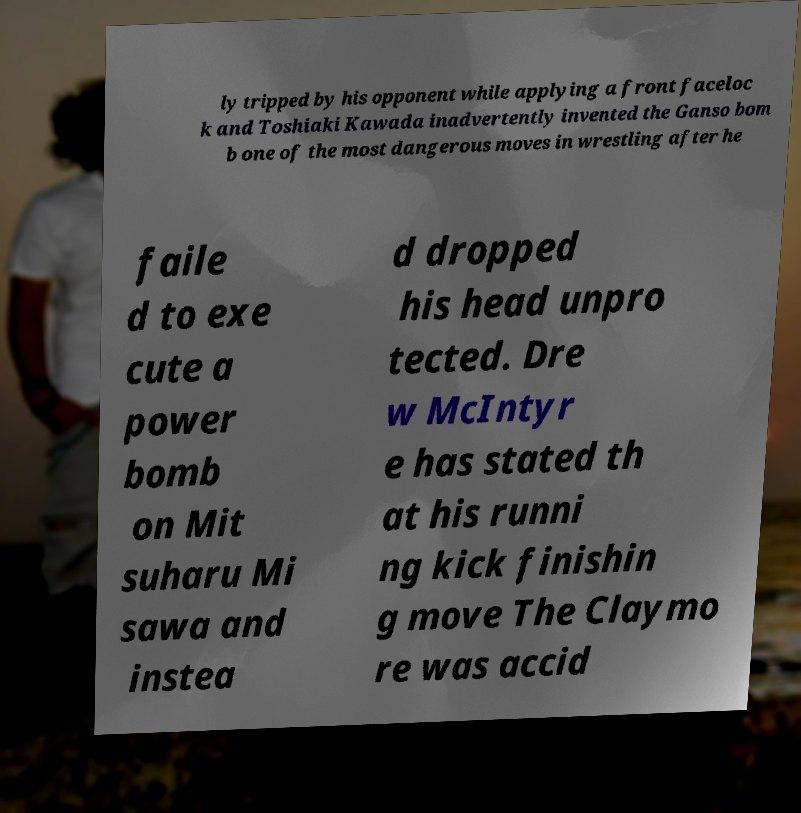I need the written content from this picture converted into text. Can you do that? ly tripped by his opponent while applying a front faceloc k and Toshiaki Kawada inadvertently invented the Ganso bom b one of the most dangerous moves in wrestling after he faile d to exe cute a power bomb on Mit suharu Mi sawa and instea d dropped his head unpro tected. Dre w McIntyr e has stated th at his runni ng kick finishin g move The Claymo re was accid 